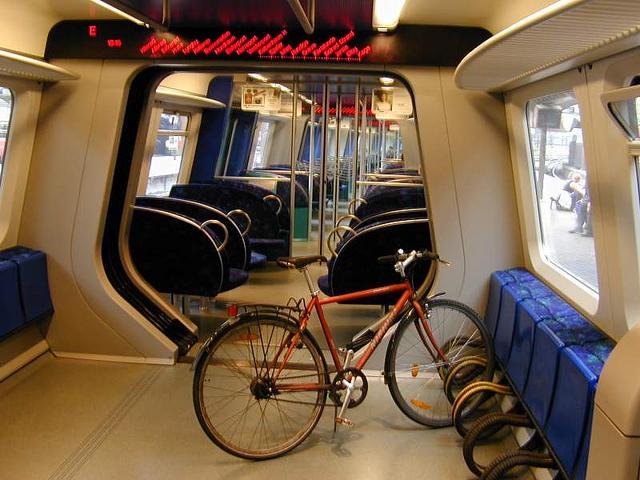Do you see a bicycle?
Give a very brief answer. Yes. Is this a train?
Write a very short answer. Yes. What color are the seats on this train?
Quick response, please. Blue. Is this mirror on a bicycle?
Keep it brief. No. 